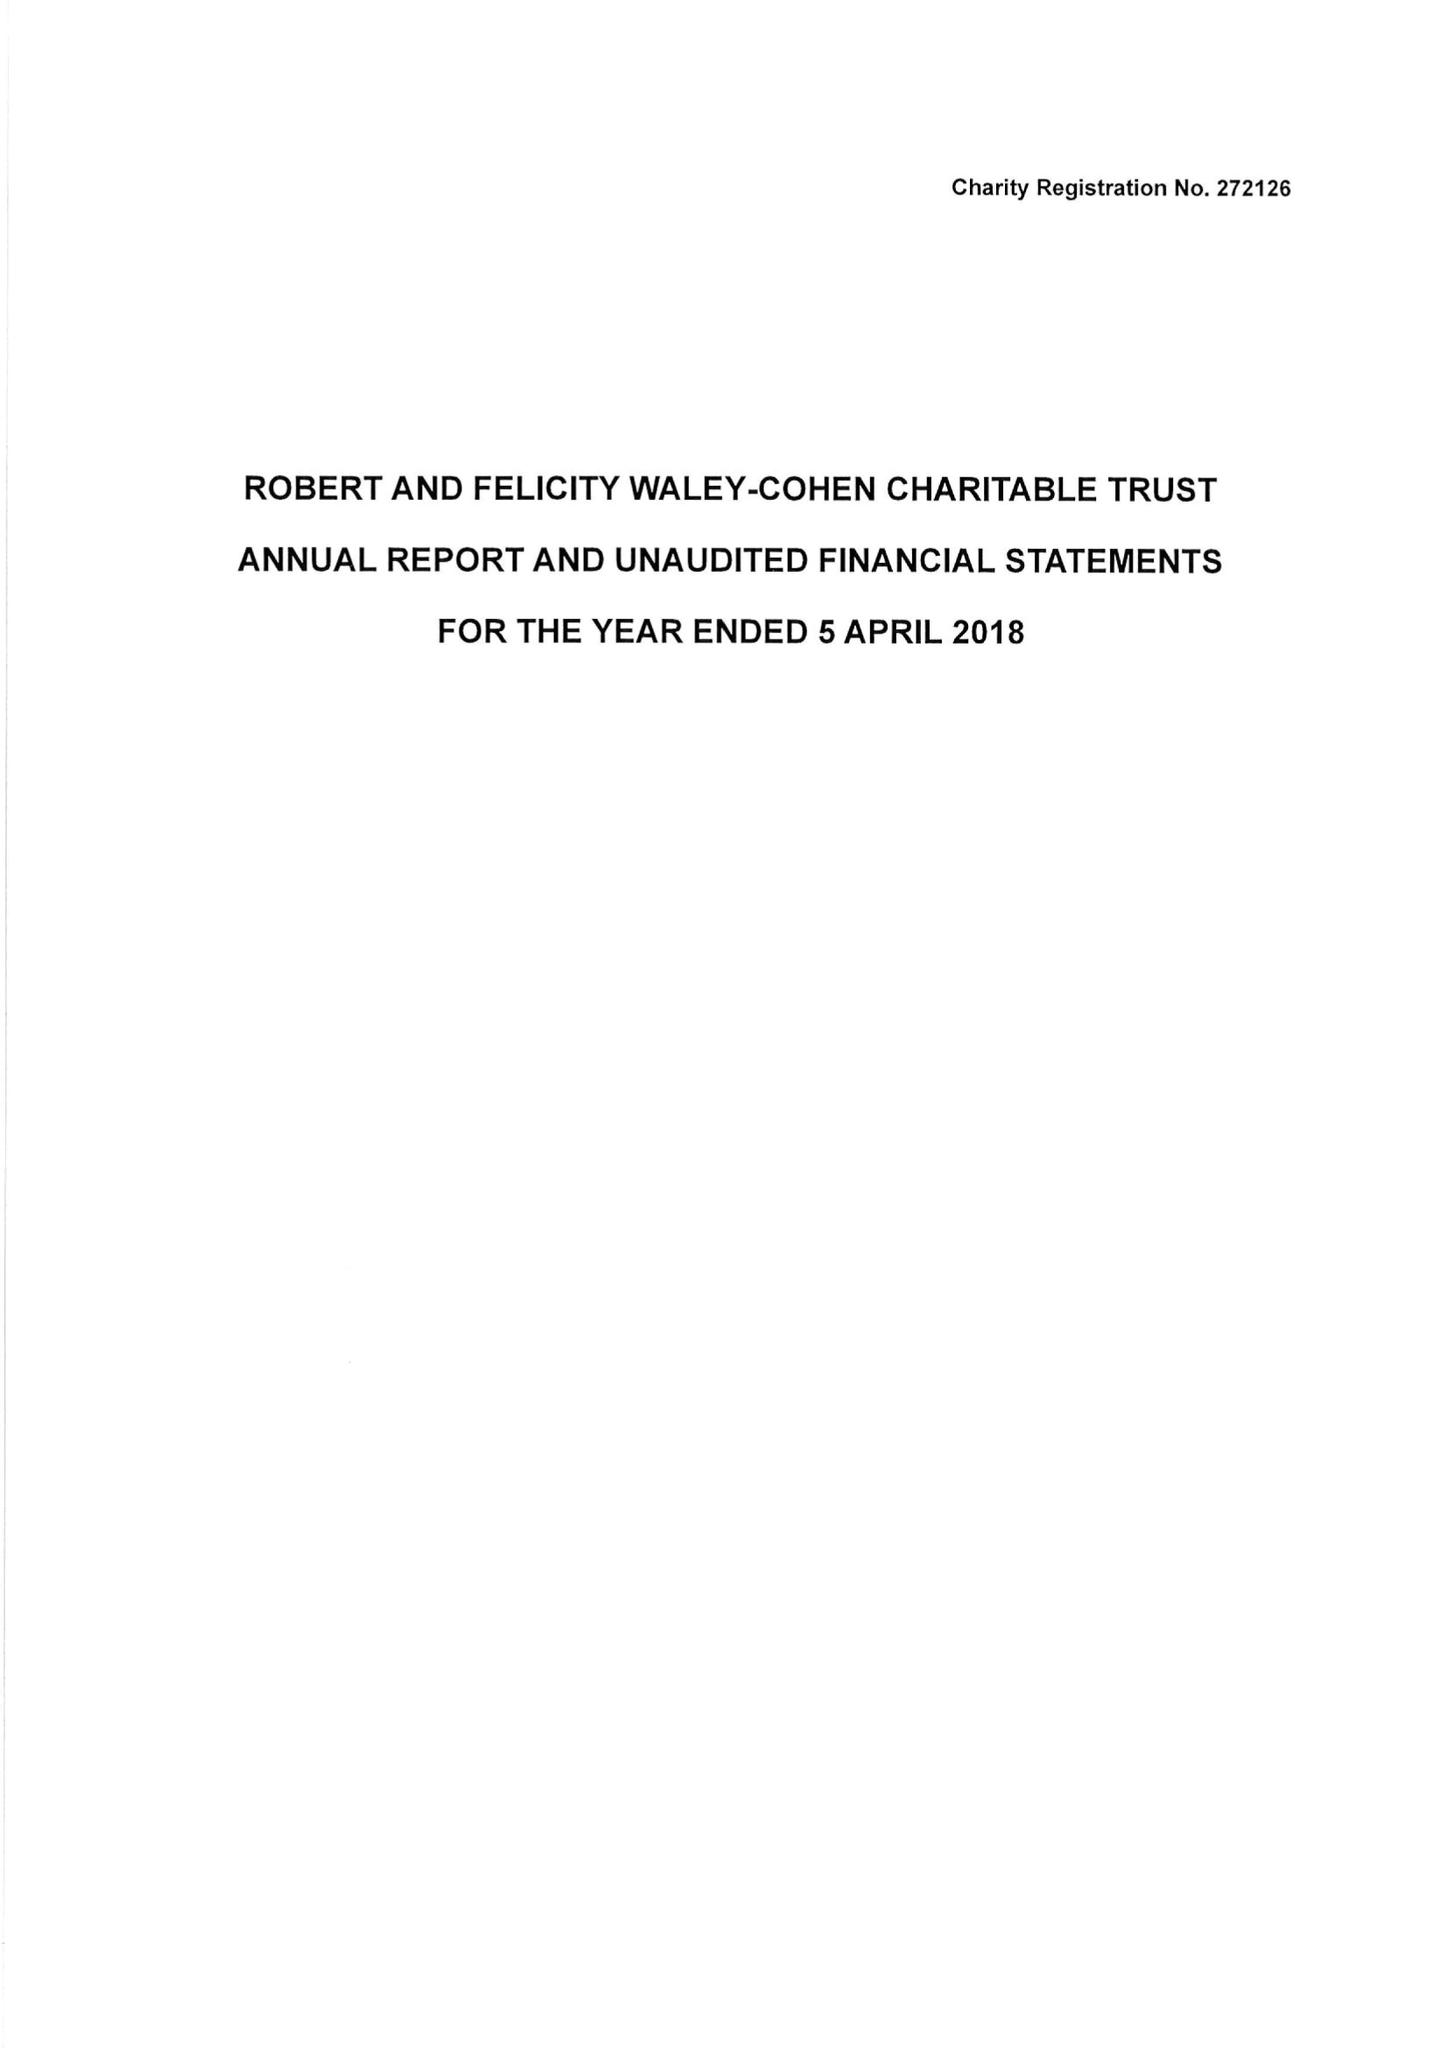What is the value for the income_annually_in_british_pounds?
Answer the question using a single word or phrase. 228558.00 